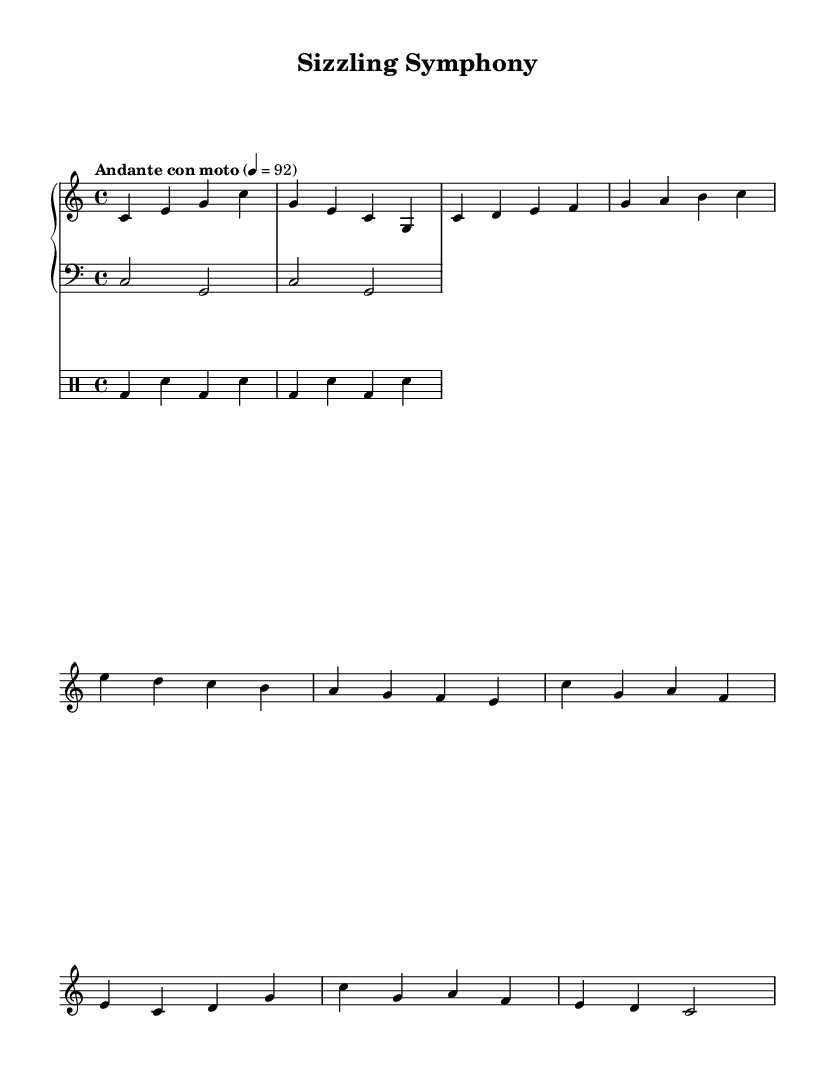What is the key signature of this music? The key signature is C major, which is identified by the absence of sharps or flats indicated at the beginning of the staff.
Answer: C major What is the time signature of this music? The time signature is shown as 4/4, meaning there are four beats in a measure and the quarter note receives one beat. This is specified at the beginning of the score.
Answer: 4/4 What is the tempo marking for this piece? The tempo marking "Andante con moto" indicates a moderately slow tempo with a sense of motion, typically represented by a metronome marking of quarter note equals 92. This marking is usually placed above the staff near the beginning of the score.
Answer: Andante con moto How many measures are in the verse section? The verse section consists of 4 measures, as counted from the provided music data, where each set of notes separated by vertical lines represents a single measure.
Answer: 4 Which instrument plays the bass line? The bass line is played by the synthesizer, which is indicated by the staff labeled as "lower" in the piano staff; this part contains a two-note pattern consistent with bass accompaniment.
Answer: Synthesizer How many different instruments are featured in the score? The score features three instruments: piano (with both upper and lower staves), synthesizer (the lower staff within the piano section), and drums (the separate drum staff). This can be deduced from the structure of the score which includes distinct sections for each part.
Answer: Three 